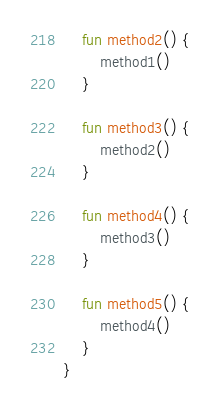<code> <loc_0><loc_0><loc_500><loc_500><_Kotlin_>
    fun method2() {
        method1()
    }

    fun method3() {
        method2()
    }

    fun method4() {
        method3()
    }

    fun method5() {
        method4()
    }
}
</code> 